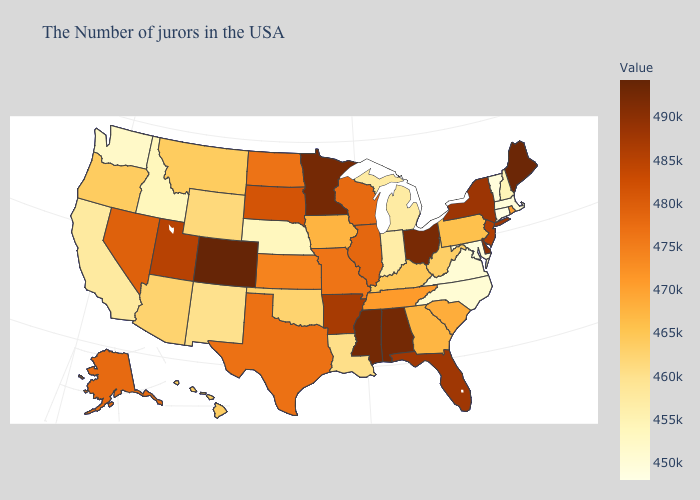Among the states that border Utah , does Wyoming have the lowest value?
Be succinct. No. Does Florida have a higher value than Colorado?
Be succinct. No. Does Arizona have the lowest value in the West?
Answer briefly. No. Among the states that border Nebraska , which have the lowest value?
Short answer required. Wyoming. Among the states that border Maryland , which have the lowest value?
Answer briefly. Virginia. Does Florida have the lowest value in the USA?
Answer briefly. No. 